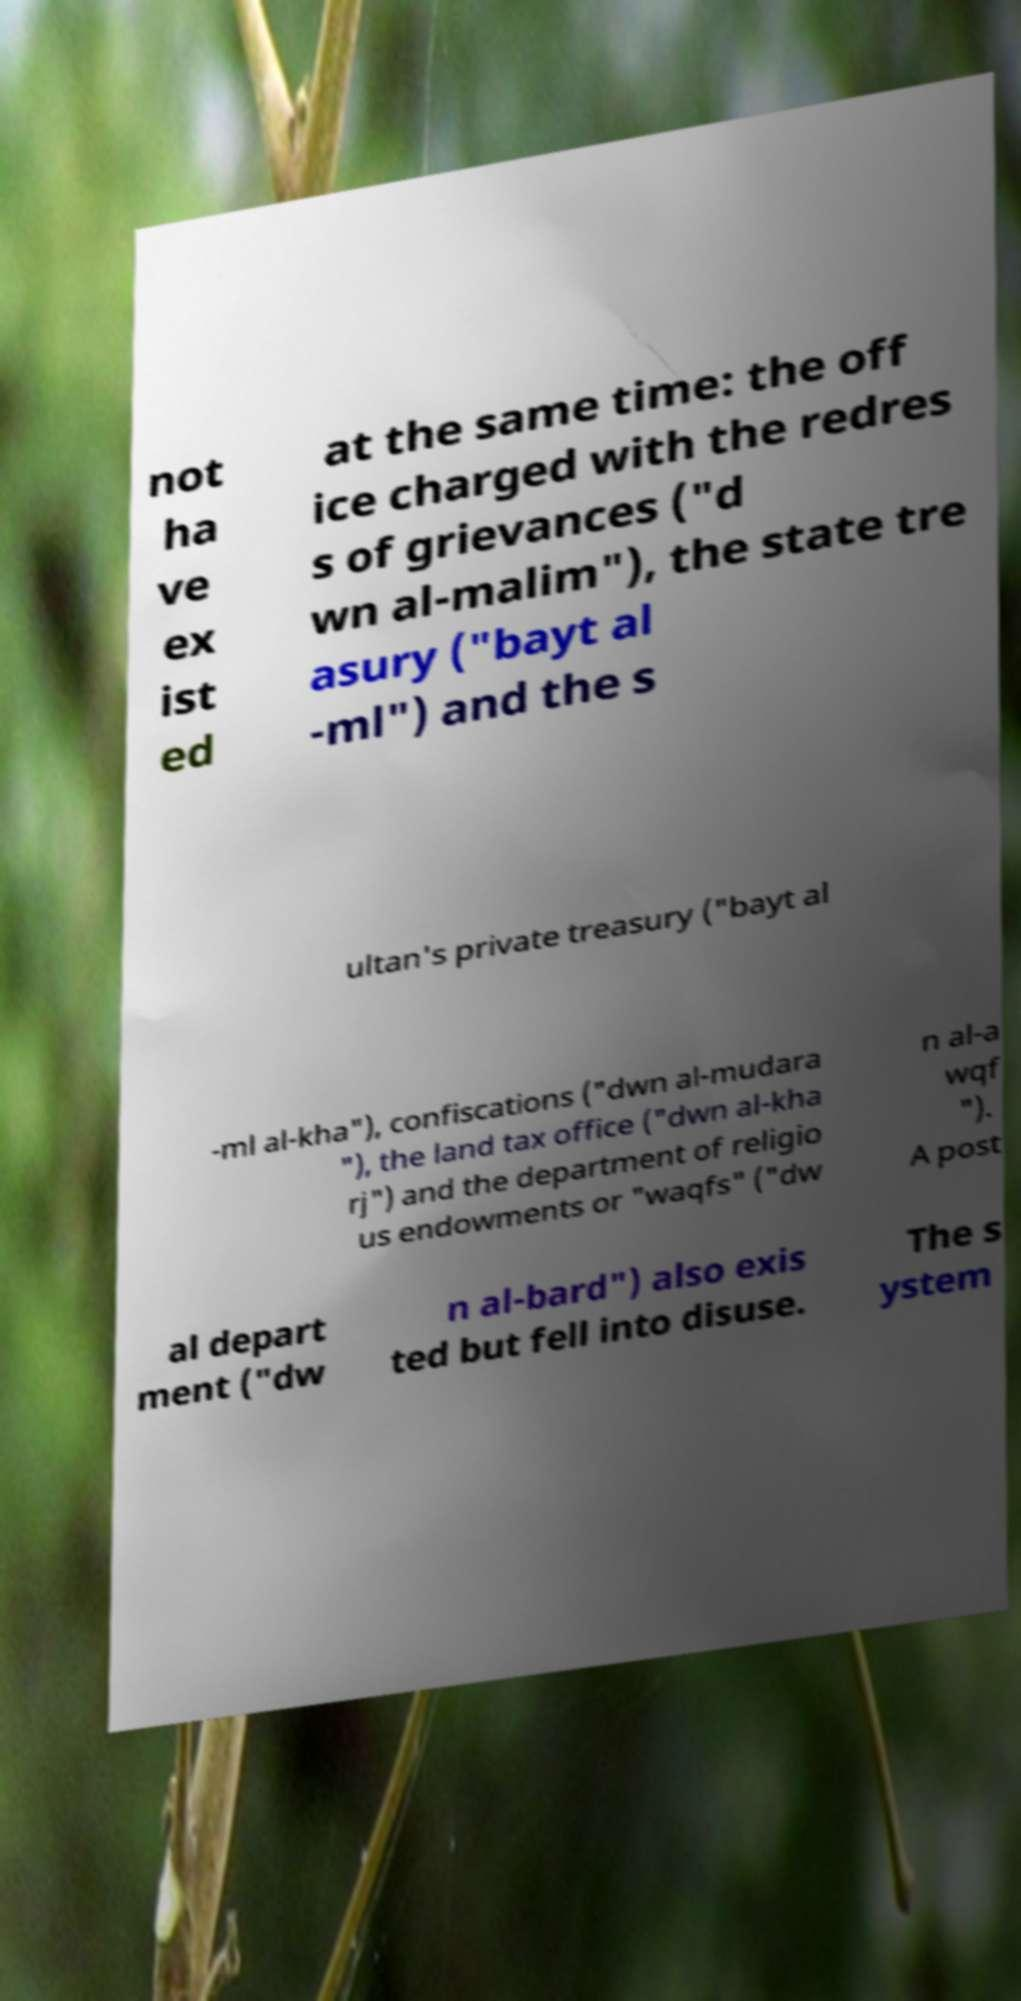Please identify and transcribe the text found in this image. not ha ve ex ist ed at the same time: the off ice charged with the redres s of grievances ("d wn al-malim"), the state tre asury ("bayt al -ml") and the s ultan's private treasury ("bayt al -ml al-kha"), confiscations ("dwn al-mudara "), the land tax office ("dwn al-kha rj") and the department of religio us endowments or "waqfs" ("dw n al-a wqf "). A post al depart ment ("dw n al-bard") also exis ted but fell into disuse. The s ystem 